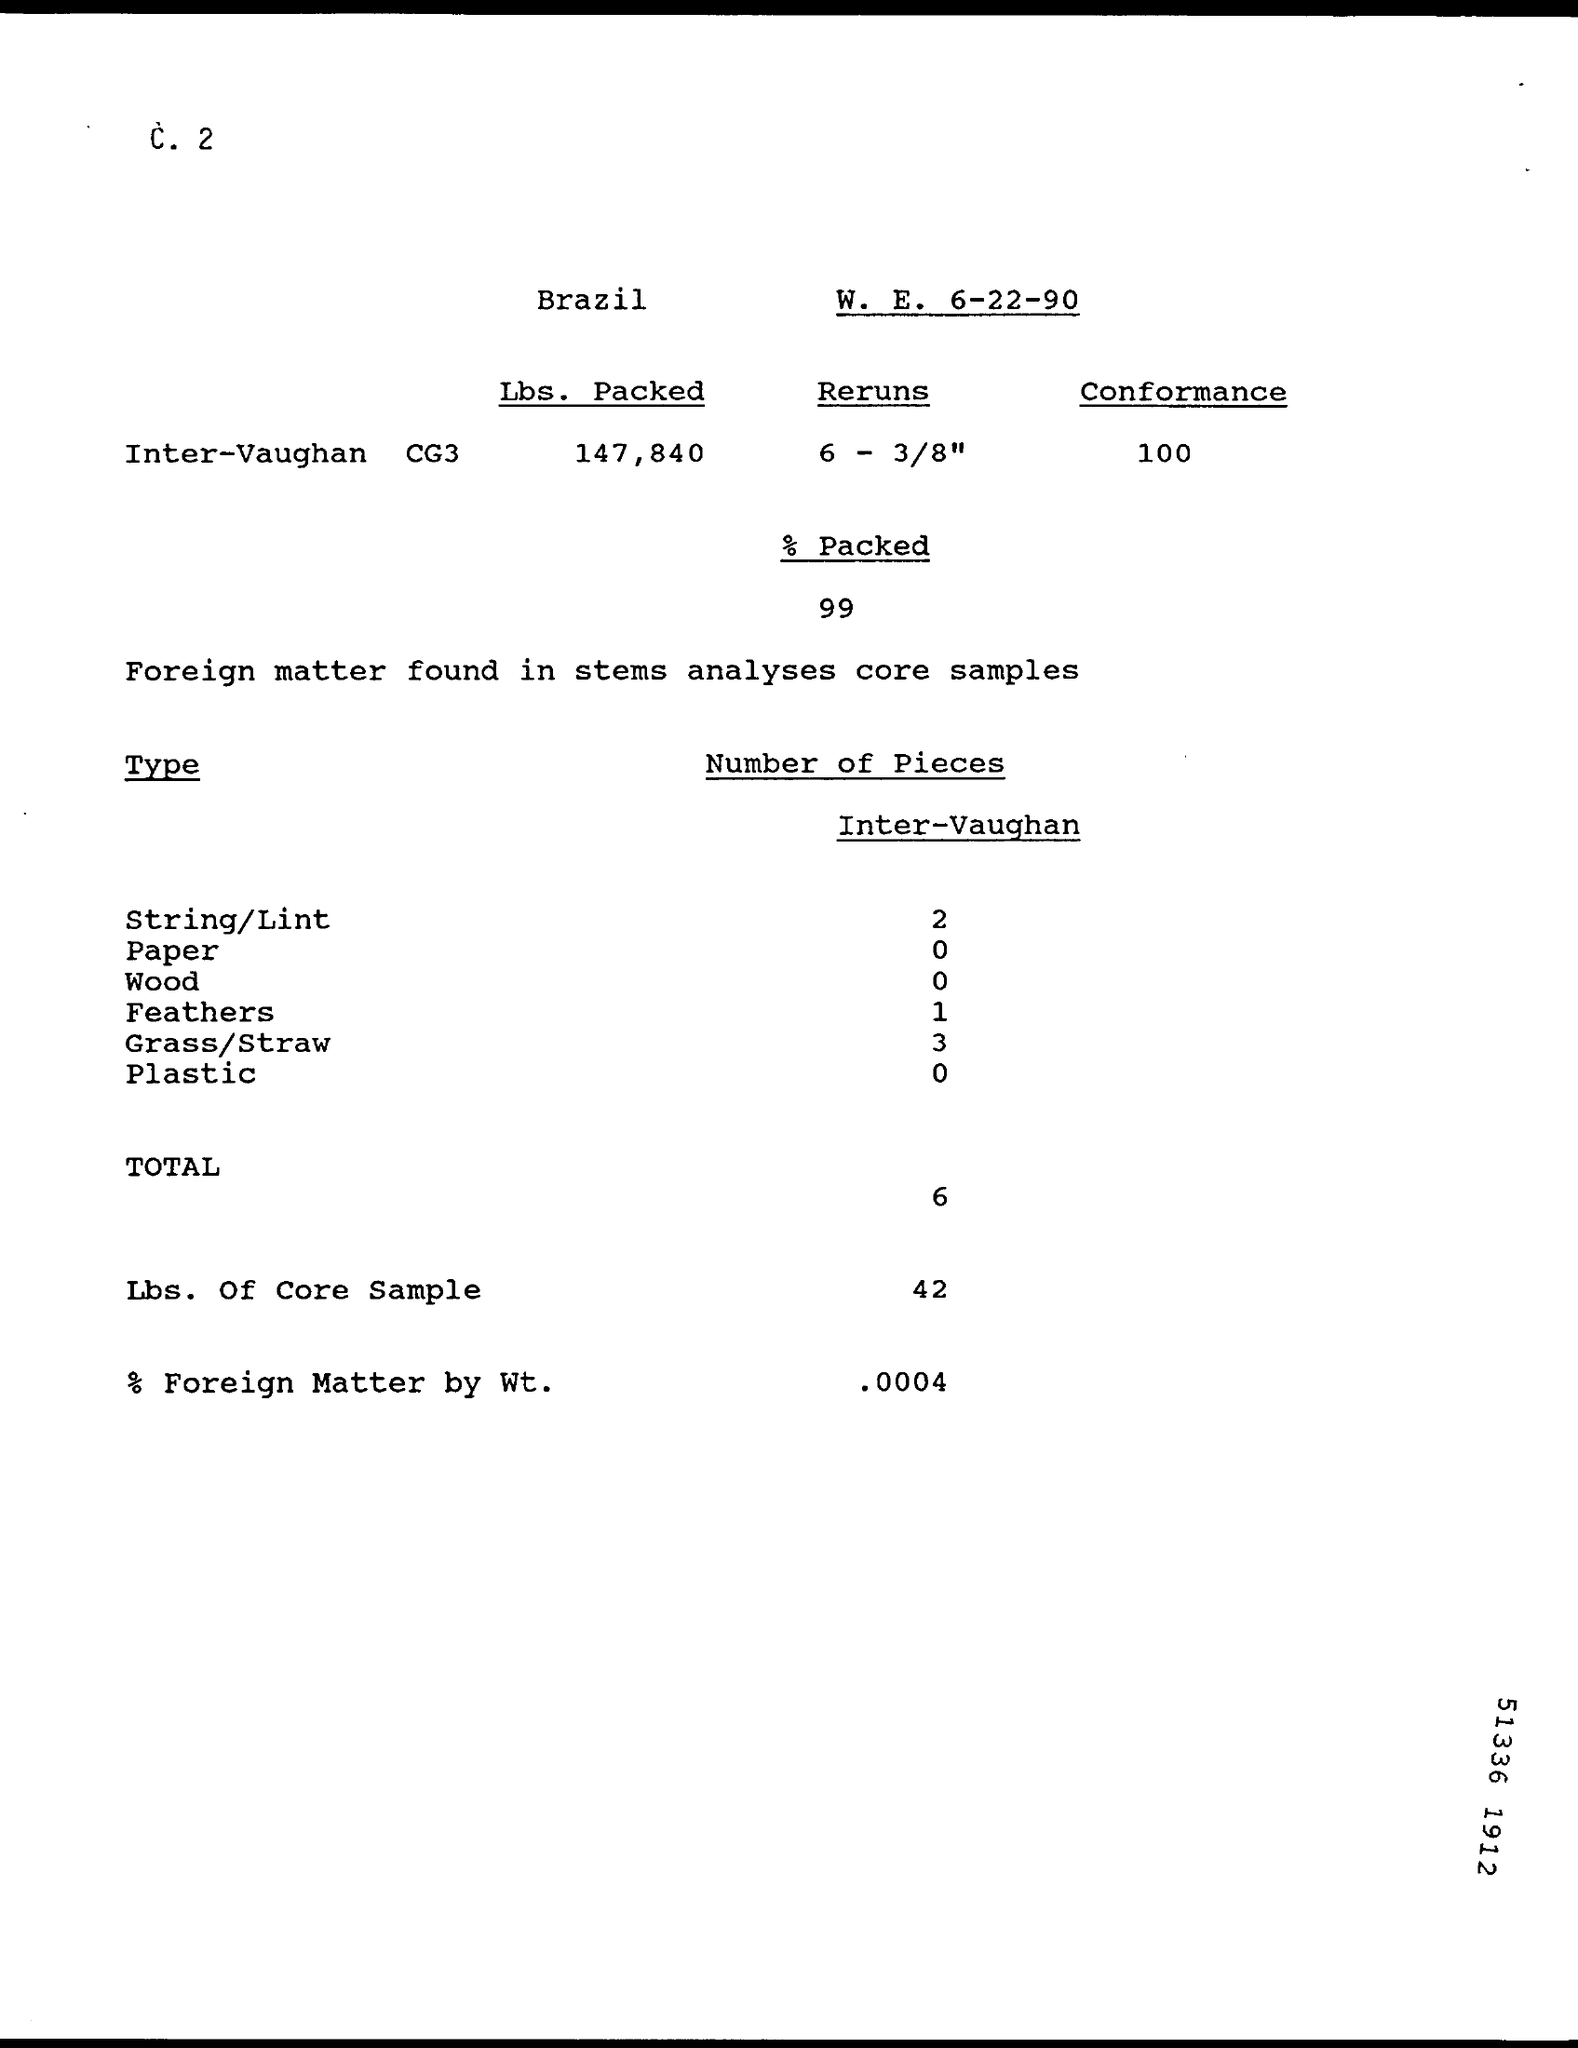What percent of foreign matter by wt. was found?
Offer a very short reply. .0004. How many pieces of grass/straw were found in the sample?
Ensure brevity in your answer.  3. What is the weight in Lbs. of core sample?
Your answer should be compact. 42. 